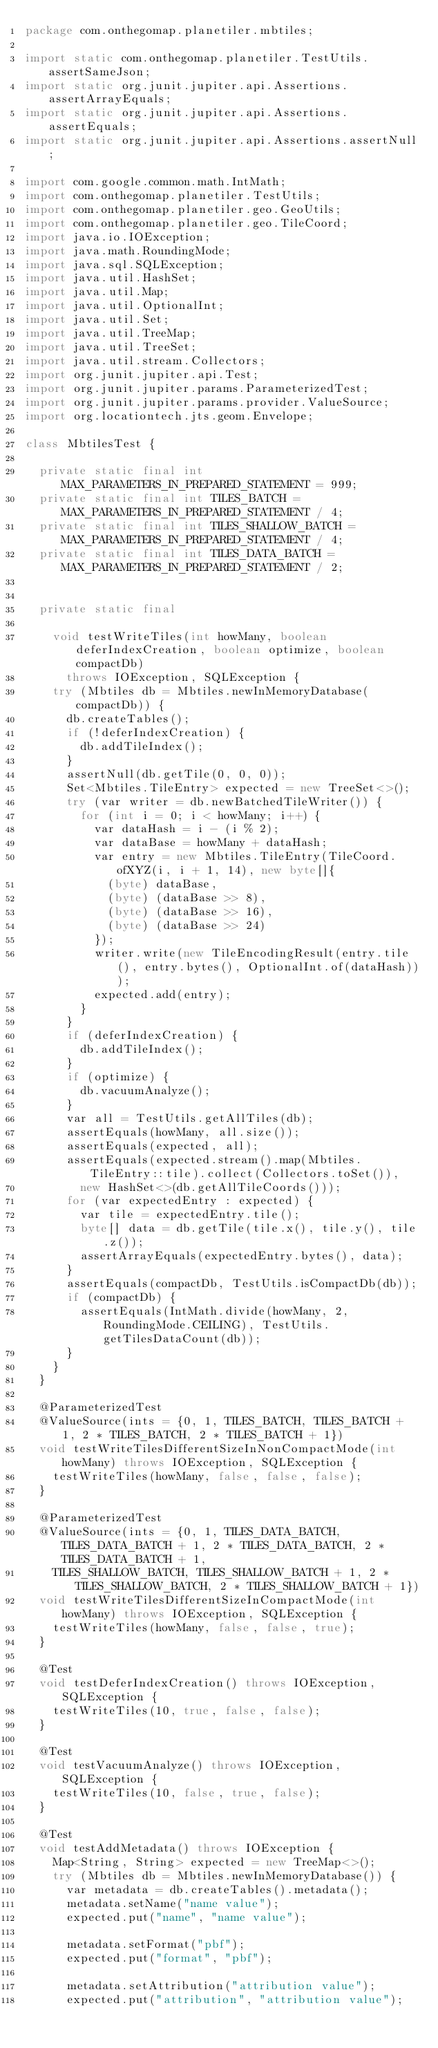<code> <loc_0><loc_0><loc_500><loc_500><_Java_>package com.onthegomap.planetiler.mbtiles;

import static com.onthegomap.planetiler.TestUtils.assertSameJson;
import static org.junit.jupiter.api.Assertions.assertArrayEquals;
import static org.junit.jupiter.api.Assertions.assertEquals;
import static org.junit.jupiter.api.Assertions.assertNull;

import com.google.common.math.IntMath;
import com.onthegomap.planetiler.TestUtils;
import com.onthegomap.planetiler.geo.GeoUtils;
import com.onthegomap.planetiler.geo.TileCoord;
import java.io.IOException;
import java.math.RoundingMode;
import java.sql.SQLException;
import java.util.HashSet;
import java.util.Map;
import java.util.OptionalInt;
import java.util.Set;
import java.util.TreeMap;
import java.util.TreeSet;
import java.util.stream.Collectors;
import org.junit.jupiter.api.Test;
import org.junit.jupiter.params.ParameterizedTest;
import org.junit.jupiter.params.provider.ValueSource;
import org.locationtech.jts.geom.Envelope;

class MbtilesTest {

  private static final int MAX_PARAMETERS_IN_PREPARED_STATEMENT = 999;
  private static final int TILES_BATCH = MAX_PARAMETERS_IN_PREPARED_STATEMENT / 4;
  private static final int TILES_SHALLOW_BATCH = MAX_PARAMETERS_IN_PREPARED_STATEMENT / 4;
  private static final int TILES_DATA_BATCH = MAX_PARAMETERS_IN_PREPARED_STATEMENT / 2;


  private static final

    void testWriteTiles(int howMany, boolean deferIndexCreation, boolean optimize, boolean compactDb)
      throws IOException, SQLException {
    try (Mbtiles db = Mbtiles.newInMemoryDatabase(compactDb)) {
      db.createTables();
      if (!deferIndexCreation) {
        db.addTileIndex();
      }
      assertNull(db.getTile(0, 0, 0));
      Set<Mbtiles.TileEntry> expected = new TreeSet<>();
      try (var writer = db.newBatchedTileWriter()) {
        for (int i = 0; i < howMany; i++) {
          var dataHash = i - (i % 2);
          var dataBase = howMany + dataHash;
          var entry = new Mbtiles.TileEntry(TileCoord.ofXYZ(i, i + 1, 14), new byte[]{
            (byte) dataBase,
            (byte) (dataBase >> 8),
            (byte) (dataBase >> 16),
            (byte) (dataBase >> 24)
          });
          writer.write(new TileEncodingResult(entry.tile(), entry.bytes(), OptionalInt.of(dataHash)));
          expected.add(entry);
        }
      }
      if (deferIndexCreation) {
        db.addTileIndex();
      }
      if (optimize) {
        db.vacuumAnalyze();
      }
      var all = TestUtils.getAllTiles(db);
      assertEquals(howMany, all.size());
      assertEquals(expected, all);
      assertEquals(expected.stream().map(Mbtiles.TileEntry::tile).collect(Collectors.toSet()),
        new HashSet<>(db.getAllTileCoords()));
      for (var expectedEntry : expected) {
        var tile = expectedEntry.tile();
        byte[] data = db.getTile(tile.x(), tile.y(), tile.z());
        assertArrayEquals(expectedEntry.bytes(), data);
      }
      assertEquals(compactDb, TestUtils.isCompactDb(db));
      if (compactDb) {
        assertEquals(IntMath.divide(howMany, 2, RoundingMode.CEILING), TestUtils.getTilesDataCount(db));
      }
    }
  }

  @ParameterizedTest
  @ValueSource(ints = {0, 1, TILES_BATCH, TILES_BATCH + 1, 2 * TILES_BATCH, 2 * TILES_BATCH + 1})
  void testWriteTilesDifferentSizeInNonCompactMode(int howMany) throws IOException, SQLException {
    testWriteTiles(howMany, false, false, false);
  }

  @ParameterizedTest
  @ValueSource(ints = {0, 1, TILES_DATA_BATCH, TILES_DATA_BATCH + 1, 2 * TILES_DATA_BATCH, 2 * TILES_DATA_BATCH + 1,
    TILES_SHALLOW_BATCH, TILES_SHALLOW_BATCH + 1, 2 * TILES_SHALLOW_BATCH, 2 * TILES_SHALLOW_BATCH + 1})
  void testWriteTilesDifferentSizeInCompactMode(int howMany) throws IOException, SQLException {
    testWriteTiles(howMany, false, false, true);
  }

  @Test
  void testDeferIndexCreation() throws IOException, SQLException {
    testWriteTiles(10, true, false, false);
  }

  @Test
  void testVacuumAnalyze() throws IOException, SQLException {
    testWriteTiles(10, false, true, false);
  }

  @Test
  void testAddMetadata() throws IOException {
    Map<String, String> expected = new TreeMap<>();
    try (Mbtiles db = Mbtiles.newInMemoryDatabase()) {
      var metadata = db.createTables().metadata();
      metadata.setName("name value");
      expected.put("name", "name value");

      metadata.setFormat("pbf");
      expected.put("format", "pbf");

      metadata.setAttribution("attribution value");
      expected.put("attribution", "attribution value");
</code> 